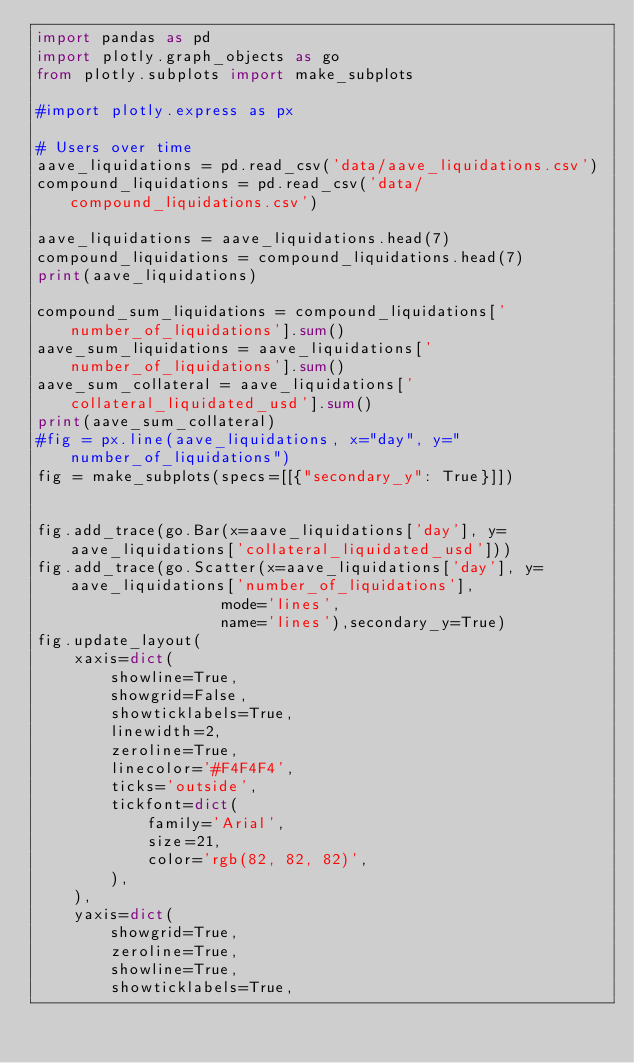<code> <loc_0><loc_0><loc_500><loc_500><_Python_>import pandas as pd 
import plotly.graph_objects as go
from plotly.subplots import make_subplots

#import plotly.express as px

# Users over time 
aave_liquidations = pd.read_csv('data/aave_liquidations.csv')  
compound_liquidations = pd.read_csv('data/compound_liquidations.csv')  

aave_liquidations = aave_liquidations.head(7)
compound_liquidations = compound_liquidations.head(7)
print(aave_liquidations)

compound_sum_liquidations = compound_liquidations['number_of_liquidations'].sum()
aave_sum_liquidations = aave_liquidations['number_of_liquidations'].sum()
aave_sum_collateral = aave_liquidations['collateral_liquidated_usd'].sum()
print(aave_sum_collateral)
#fig = px.line(aave_liquidations, x="day", y="number_of_liquidations")
fig = make_subplots(specs=[[{"secondary_y": True}]])


fig.add_trace(go.Bar(x=aave_liquidations['day'], y=aave_liquidations['collateral_liquidated_usd']))
fig.add_trace(go.Scatter(x=aave_liquidations['day'], y=aave_liquidations['number_of_liquidations'],
                    mode='lines',
                    name='lines'),secondary_y=True)
fig.update_layout(
    xaxis=dict(
        showline=True,
        showgrid=False,
        showticklabels=True,
        linewidth=2,
        zeroline=True,
        linecolor='#F4F4F4',
        ticks='outside',
        tickfont=dict(
            family='Arial',
            size=21,
            color='rgb(82, 82, 82)',
        ),
    ),
    yaxis=dict(
        showgrid=True,
        zeroline=True,
        showline=True,
        showticklabels=True,</code> 